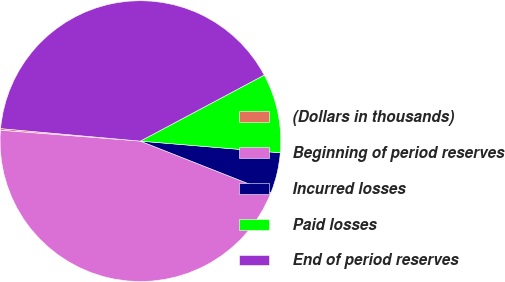<chart> <loc_0><loc_0><loc_500><loc_500><pie_chart><fcel>(Dollars in thousands)<fcel>Beginning of period reserves<fcel>Incurred losses<fcel>Paid losses<fcel>End of period reserves<nl><fcel>0.19%<fcel>45.25%<fcel>4.65%<fcel>9.12%<fcel>40.78%<nl></chart> 